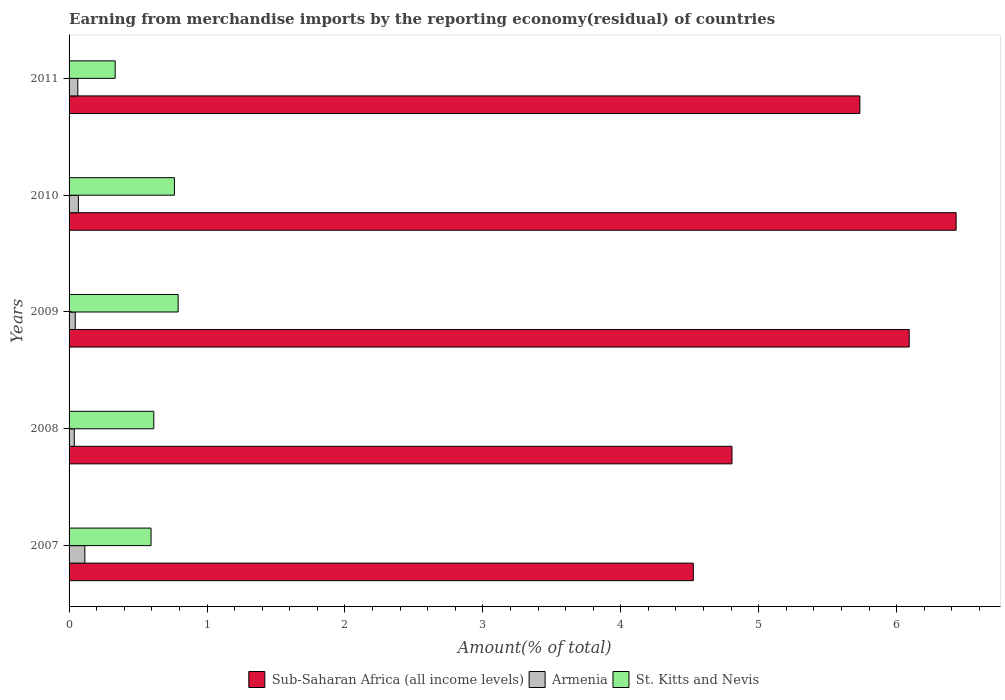How many groups of bars are there?
Your response must be concise. 5. How many bars are there on the 4th tick from the bottom?
Keep it short and to the point. 3. What is the label of the 5th group of bars from the top?
Offer a terse response. 2007. In how many cases, is the number of bars for a given year not equal to the number of legend labels?
Your answer should be compact. 0. What is the percentage of amount earned from merchandise imports in Armenia in 2011?
Provide a short and direct response. 0.06. Across all years, what is the maximum percentage of amount earned from merchandise imports in Armenia?
Ensure brevity in your answer.  0.11. Across all years, what is the minimum percentage of amount earned from merchandise imports in Sub-Saharan Africa (all income levels)?
Provide a short and direct response. 4.53. In which year was the percentage of amount earned from merchandise imports in Armenia maximum?
Your answer should be compact. 2007. What is the total percentage of amount earned from merchandise imports in Sub-Saharan Africa (all income levels) in the graph?
Your answer should be compact. 27.59. What is the difference between the percentage of amount earned from merchandise imports in Sub-Saharan Africa (all income levels) in 2008 and that in 2010?
Keep it short and to the point. -1.63. What is the difference between the percentage of amount earned from merchandise imports in Sub-Saharan Africa (all income levels) in 2011 and the percentage of amount earned from merchandise imports in Armenia in 2007?
Make the answer very short. 5.62. What is the average percentage of amount earned from merchandise imports in Armenia per year?
Offer a terse response. 0.07. In the year 2011, what is the difference between the percentage of amount earned from merchandise imports in Armenia and percentage of amount earned from merchandise imports in Sub-Saharan Africa (all income levels)?
Ensure brevity in your answer.  -5.67. What is the ratio of the percentage of amount earned from merchandise imports in Armenia in 2008 to that in 2009?
Offer a very short reply. 0.84. Is the percentage of amount earned from merchandise imports in Armenia in 2008 less than that in 2011?
Provide a short and direct response. Yes. Is the difference between the percentage of amount earned from merchandise imports in Armenia in 2008 and 2011 greater than the difference between the percentage of amount earned from merchandise imports in Sub-Saharan Africa (all income levels) in 2008 and 2011?
Ensure brevity in your answer.  Yes. What is the difference between the highest and the second highest percentage of amount earned from merchandise imports in Armenia?
Offer a terse response. 0.05. What is the difference between the highest and the lowest percentage of amount earned from merchandise imports in Sub-Saharan Africa (all income levels)?
Your answer should be very brief. 1.91. Is the sum of the percentage of amount earned from merchandise imports in Sub-Saharan Africa (all income levels) in 2007 and 2009 greater than the maximum percentage of amount earned from merchandise imports in St. Kitts and Nevis across all years?
Your response must be concise. Yes. What does the 2nd bar from the top in 2007 represents?
Make the answer very short. Armenia. What does the 1st bar from the bottom in 2011 represents?
Make the answer very short. Sub-Saharan Africa (all income levels). Is it the case that in every year, the sum of the percentage of amount earned from merchandise imports in St. Kitts and Nevis and percentage of amount earned from merchandise imports in Armenia is greater than the percentage of amount earned from merchandise imports in Sub-Saharan Africa (all income levels)?
Ensure brevity in your answer.  No. Does the graph contain grids?
Your answer should be compact. No. Where does the legend appear in the graph?
Provide a short and direct response. Bottom center. How many legend labels are there?
Offer a very short reply. 3. How are the legend labels stacked?
Your answer should be very brief. Horizontal. What is the title of the graph?
Your answer should be compact. Earning from merchandise imports by the reporting economy(residual) of countries. Does "Somalia" appear as one of the legend labels in the graph?
Provide a short and direct response. No. What is the label or title of the X-axis?
Give a very brief answer. Amount(% of total). What is the Amount(% of total) in Sub-Saharan Africa (all income levels) in 2007?
Offer a terse response. 4.53. What is the Amount(% of total) in Armenia in 2007?
Provide a succinct answer. 0.11. What is the Amount(% of total) of St. Kitts and Nevis in 2007?
Provide a succinct answer. 0.59. What is the Amount(% of total) in Sub-Saharan Africa (all income levels) in 2008?
Offer a very short reply. 4.81. What is the Amount(% of total) of Armenia in 2008?
Provide a short and direct response. 0.04. What is the Amount(% of total) of St. Kitts and Nevis in 2008?
Offer a terse response. 0.61. What is the Amount(% of total) of Sub-Saharan Africa (all income levels) in 2009?
Provide a succinct answer. 6.09. What is the Amount(% of total) in Armenia in 2009?
Provide a succinct answer. 0.04. What is the Amount(% of total) of St. Kitts and Nevis in 2009?
Ensure brevity in your answer.  0.79. What is the Amount(% of total) of Sub-Saharan Africa (all income levels) in 2010?
Provide a short and direct response. 6.43. What is the Amount(% of total) of Armenia in 2010?
Your response must be concise. 0.07. What is the Amount(% of total) in St. Kitts and Nevis in 2010?
Provide a succinct answer. 0.76. What is the Amount(% of total) of Sub-Saharan Africa (all income levels) in 2011?
Your response must be concise. 5.73. What is the Amount(% of total) of Armenia in 2011?
Your response must be concise. 0.06. What is the Amount(% of total) of St. Kitts and Nevis in 2011?
Provide a short and direct response. 0.33. Across all years, what is the maximum Amount(% of total) of Sub-Saharan Africa (all income levels)?
Ensure brevity in your answer.  6.43. Across all years, what is the maximum Amount(% of total) in Armenia?
Your answer should be very brief. 0.11. Across all years, what is the maximum Amount(% of total) in St. Kitts and Nevis?
Offer a very short reply. 0.79. Across all years, what is the minimum Amount(% of total) of Sub-Saharan Africa (all income levels)?
Give a very brief answer. 4.53. Across all years, what is the minimum Amount(% of total) of Armenia?
Keep it short and to the point. 0.04. Across all years, what is the minimum Amount(% of total) in St. Kitts and Nevis?
Offer a very short reply. 0.33. What is the total Amount(% of total) in Sub-Saharan Africa (all income levels) in the graph?
Provide a succinct answer. 27.59. What is the total Amount(% of total) in Armenia in the graph?
Your answer should be compact. 0.33. What is the total Amount(% of total) in St. Kitts and Nevis in the graph?
Make the answer very short. 3.1. What is the difference between the Amount(% of total) of Sub-Saharan Africa (all income levels) in 2007 and that in 2008?
Your answer should be compact. -0.28. What is the difference between the Amount(% of total) in Armenia in 2007 and that in 2008?
Make the answer very short. 0.08. What is the difference between the Amount(% of total) of St. Kitts and Nevis in 2007 and that in 2008?
Ensure brevity in your answer.  -0.02. What is the difference between the Amount(% of total) in Sub-Saharan Africa (all income levels) in 2007 and that in 2009?
Offer a very short reply. -1.57. What is the difference between the Amount(% of total) of Armenia in 2007 and that in 2009?
Your answer should be very brief. 0.07. What is the difference between the Amount(% of total) in St. Kitts and Nevis in 2007 and that in 2009?
Offer a very short reply. -0.2. What is the difference between the Amount(% of total) of Sub-Saharan Africa (all income levels) in 2007 and that in 2010?
Your answer should be compact. -1.91. What is the difference between the Amount(% of total) of Armenia in 2007 and that in 2010?
Keep it short and to the point. 0.05. What is the difference between the Amount(% of total) in St. Kitts and Nevis in 2007 and that in 2010?
Keep it short and to the point. -0.17. What is the difference between the Amount(% of total) in Sub-Saharan Africa (all income levels) in 2007 and that in 2011?
Offer a very short reply. -1.21. What is the difference between the Amount(% of total) of Armenia in 2007 and that in 2011?
Give a very brief answer. 0.05. What is the difference between the Amount(% of total) in St. Kitts and Nevis in 2007 and that in 2011?
Make the answer very short. 0.26. What is the difference between the Amount(% of total) in Sub-Saharan Africa (all income levels) in 2008 and that in 2009?
Ensure brevity in your answer.  -1.28. What is the difference between the Amount(% of total) in Armenia in 2008 and that in 2009?
Make the answer very short. -0.01. What is the difference between the Amount(% of total) of St. Kitts and Nevis in 2008 and that in 2009?
Offer a very short reply. -0.18. What is the difference between the Amount(% of total) of Sub-Saharan Africa (all income levels) in 2008 and that in 2010?
Offer a very short reply. -1.63. What is the difference between the Amount(% of total) of Armenia in 2008 and that in 2010?
Offer a terse response. -0.03. What is the difference between the Amount(% of total) of St. Kitts and Nevis in 2008 and that in 2010?
Your answer should be compact. -0.15. What is the difference between the Amount(% of total) of Sub-Saharan Africa (all income levels) in 2008 and that in 2011?
Your response must be concise. -0.93. What is the difference between the Amount(% of total) of Armenia in 2008 and that in 2011?
Keep it short and to the point. -0.03. What is the difference between the Amount(% of total) in St. Kitts and Nevis in 2008 and that in 2011?
Provide a short and direct response. 0.28. What is the difference between the Amount(% of total) in Sub-Saharan Africa (all income levels) in 2009 and that in 2010?
Make the answer very short. -0.34. What is the difference between the Amount(% of total) in Armenia in 2009 and that in 2010?
Your answer should be compact. -0.02. What is the difference between the Amount(% of total) in St. Kitts and Nevis in 2009 and that in 2010?
Keep it short and to the point. 0.03. What is the difference between the Amount(% of total) of Sub-Saharan Africa (all income levels) in 2009 and that in 2011?
Offer a very short reply. 0.36. What is the difference between the Amount(% of total) of Armenia in 2009 and that in 2011?
Your response must be concise. -0.02. What is the difference between the Amount(% of total) in St. Kitts and Nevis in 2009 and that in 2011?
Give a very brief answer. 0.46. What is the difference between the Amount(% of total) in Sub-Saharan Africa (all income levels) in 2010 and that in 2011?
Ensure brevity in your answer.  0.7. What is the difference between the Amount(% of total) of Armenia in 2010 and that in 2011?
Keep it short and to the point. 0. What is the difference between the Amount(% of total) of St. Kitts and Nevis in 2010 and that in 2011?
Provide a succinct answer. 0.43. What is the difference between the Amount(% of total) in Sub-Saharan Africa (all income levels) in 2007 and the Amount(% of total) in Armenia in 2008?
Provide a succinct answer. 4.49. What is the difference between the Amount(% of total) in Sub-Saharan Africa (all income levels) in 2007 and the Amount(% of total) in St. Kitts and Nevis in 2008?
Your answer should be very brief. 3.91. What is the difference between the Amount(% of total) of Sub-Saharan Africa (all income levels) in 2007 and the Amount(% of total) of Armenia in 2009?
Provide a short and direct response. 4.48. What is the difference between the Amount(% of total) in Sub-Saharan Africa (all income levels) in 2007 and the Amount(% of total) in St. Kitts and Nevis in 2009?
Provide a succinct answer. 3.73. What is the difference between the Amount(% of total) of Armenia in 2007 and the Amount(% of total) of St. Kitts and Nevis in 2009?
Provide a short and direct response. -0.68. What is the difference between the Amount(% of total) in Sub-Saharan Africa (all income levels) in 2007 and the Amount(% of total) in Armenia in 2010?
Provide a short and direct response. 4.46. What is the difference between the Amount(% of total) in Sub-Saharan Africa (all income levels) in 2007 and the Amount(% of total) in St. Kitts and Nevis in 2010?
Offer a terse response. 3.76. What is the difference between the Amount(% of total) of Armenia in 2007 and the Amount(% of total) of St. Kitts and Nevis in 2010?
Provide a succinct answer. -0.65. What is the difference between the Amount(% of total) of Sub-Saharan Africa (all income levels) in 2007 and the Amount(% of total) of Armenia in 2011?
Offer a terse response. 4.46. What is the difference between the Amount(% of total) in Sub-Saharan Africa (all income levels) in 2007 and the Amount(% of total) in St. Kitts and Nevis in 2011?
Offer a terse response. 4.19. What is the difference between the Amount(% of total) in Armenia in 2007 and the Amount(% of total) in St. Kitts and Nevis in 2011?
Keep it short and to the point. -0.22. What is the difference between the Amount(% of total) in Sub-Saharan Africa (all income levels) in 2008 and the Amount(% of total) in Armenia in 2009?
Your answer should be compact. 4.76. What is the difference between the Amount(% of total) in Sub-Saharan Africa (all income levels) in 2008 and the Amount(% of total) in St. Kitts and Nevis in 2009?
Your response must be concise. 4.02. What is the difference between the Amount(% of total) of Armenia in 2008 and the Amount(% of total) of St. Kitts and Nevis in 2009?
Keep it short and to the point. -0.75. What is the difference between the Amount(% of total) of Sub-Saharan Africa (all income levels) in 2008 and the Amount(% of total) of Armenia in 2010?
Offer a very short reply. 4.74. What is the difference between the Amount(% of total) of Sub-Saharan Africa (all income levels) in 2008 and the Amount(% of total) of St. Kitts and Nevis in 2010?
Offer a terse response. 4.04. What is the difference between the Amount(% of total) in Armenia in 2008 and the Amount(% of total) in St. Kitts and Nevis in 2010?
Make the answer very short. -0.73. What is the difference between the Amount(% of total) of Sub-Saharan Africa (all income levels) in 2008 and the Amount(% of total) of Armenia in 2011?
Provide a short and direct response. 4.74. What is the difference between the Amount(% of total) in Sub-Saharan Africa (all income levels) in 2008 and the Amount(% of total) in St. Kitts and Nevis in 2011?
Your answer should be very brief. 4.47. What is the difference between the Amount(% of total) in Armenia in 2008 and the Amount(% of total) in St. Kitts and Nevis in 2011?
Offer a terse response. -0.3. What is the difference between the Amount(% of total) in Sub-Saharan Africa (all income levels) in 2009 and the Amount(% of total) in Armenia in 2010?
Provide a succinct answer. 6.02. What is the difference between the Amount(% of total) of Sub-Saharan Africa (all income levels) in 2009 and the Amount(% of total) of St. Kitts and Nevis in 2010?
Ensure brevity in your answer.  5.33. What is the difference between the Amount(% of total) in Armenia in 2009 and the Amount(% of total) in St. Kitts and Nevis in 2010?
Keep it short and to the point. -0.72. What is the difference between the Amount(% of total) of Sub-Saharan Africa (all income levels) in 2009 and the Amount(% of total) of Armenia in 2011?
Provide a short and direct response. 6.03. What is the difference between the Amount(% of total) in Sub-Saharan Africa (all income levels) in 2009 and the Amount(% of total) in St. Kitts and Nevis in 2011?
Give a very brief answer. 5.76. What is the difference between the Amount(% of total) of Armenia in 2009 and the Amount(% of total) of St. Kitts and Nevis in 2011?
Ensure brevity in your answer.  -0.29. What is the difference between the Amount(% of total) of Sub-Saharan Africa (all income levels) in 2010 and the Amount(% of total) of Armenia in 2011?
Provide a succinct answer. 6.37. What is the difference between the Amount(% of total) of Sub-Saharan Africa (all income levels) in 2010 and the Amount(% of total) of St. Kitts and Nevis in 2011?
Your answer should be very brief. 6.1. What is the difference between the Amount(% of total) in Armenia in 2010 and the Amount(% of total) in St. Kitts and Nevis in 2011?
Your response must be concise. -0.27. What is the average Amount(% of total) of Sub-Saharan Africa (all income levels) per year?
Provide a short and direct response. 5.52. What is the average Amount(% of total) in Armenia per year?
Your response must be concise. 0.07. What is the average Amount(% of total) in St. Kitts and Nevis per year?
Provide a succinct answer. 0.62. In the year 2007, what is the difference between the Amount(% of total) of Sub-Saharan Africa (all income levels) and Amount(% of total) of Armenia?
Keep it short and to the point. 4.41. In the year 2007, what is the difference between the Amount(% of total) of Sub-Saharan Africa (all income levels) and Amount(% of total) of St. Kitts and Nevis?
Your response must be concise. 3.93. In the year 2007, what is the difference between the Amount(% of total) in Armenia and Amount(% of total) in St. Kitts and Nevis?
Provide a succinct answer. -0.48. In the year 2008, what is the difference between the Amount(% of total) of Sub-Saharan Africa (all income levels) and Amount(% of total) of Armenia?
Provide a short and direct response. 4.77. In the year 2008, what is the difference between the Amount(% of total) of Sub-Saharan Africa (all income levels) and Amount(% of total) of St. Kitts and Nevis?
Your response must be concise. 4.19. In the year 2008, what is the difference between the Amount(% of total) of Armenia and Amount(% of total) of St. Kitts and Nevis?
Make the answer very short. -0.58. In the year 2009, what is the difference between the Amount(% of total) in Sub-Saharan Africa (all income levels) and Amount(% of total) in Armenia?
Provide a succinct answer. 6.05. In the year 2009, what is the difference between the Amount(% of total) in Armenia and Amount(% of total) in St. Kitts and Nevis?
Your answer should be very brief. -0.75. In the year 2010, what is the difference between the Amount(% of total) of Sub-Saharan Africa (all income levels) and Amount(% of total) of Armenia?
Give a very brief answer. 6.36. In the year 2010, what is the difference between the Amount(% of total) in Sub-Saharan Africa (all income levels) and Amount(% of total) in St. Kitts and Nevis?
Give a very brief answer. 5.67. In the year 2010, what is the difference between the Amount(% of total) of Armenia and Amount(% of total) of St. Kitts and Nevis?
Offer a very short reply. -0.7. In the year 2011, what is the difference between the Amount(% of total) in Sub-Saharan Africa (all income levels) and Amount(% of total) in Armenia?
Your answer should be very brief. 5.67. In the year 2011, what is the difference between the Amount(% of total) of Sub-Saharan Africa (all income levels) and Amount(% of total) of St. Kitts and Nevis?
Provide a succinct answer. 5.4. In the year 2011, what is the difference between the Amount(% of total) in Armenia and Amount(% of total) in St. Kitts and Nevis?
Your answer should be compact. -0.27. What is the ratio of the Amount(% of total) of Sub-Saharan Africa (all income levels) in 2007 to that in 2008?
Make the answer very short. 0.94. What is the ratio of the Amount(% of total) in Armenia in 2007 to that in 2008?
Make the answer very short. 3.03. What is the ratio of the Amount(% of total) in St. Kitts and Nevis in 2007 to that in 2008?
Keep it short and to the point. 0.97. What is the ratio of the Amount(% of total) in Sub-Saharan Africa (all income levels) in 2007 to that in 2009?
Keep it short and to the point. 0.74. What is the ratio of the Amount(% of total) of Armenia in 2007 to that in 2009?
Your answer should be compact. 2.54. What is the ratio of the Amount(% of total) of St. Kitts and Nevis in 2007 to that in 2009?
Ensure brevity in your answer.  0.75. What is the ratio of the Amount(% of total) in Sub-Saharan Africa (all income levels) in 2007 to that in 2010?
Give a very brief answer. 0.7. What is the ratio of the Amount(% of total) of Armenia in 2007 to that in 2010?
Ensure brevity in your answer.  1.69. What is the ratio of the Amount(% of total) in St. Kitts and Nevis in 2007 to that in 2010?
Offer a terse response. 0.78. What is the ratio of the Amount(% of total) in Sub-Saharan Africa (all income levels) in 2007 to that in 2011?
Make the answer very short. 0.79. What is the ratio of the Amount(% of total) of Armenia in 2007 to that in 2011?
Offer a very short reply. 1.8. What is the ratio of the Amount(% of total) in St. Kitts and Nevis in 2007 to that in 2011?
Provide a short and direct response. 1.78. What is the ratio of the Amount(% of total) of Sub-Saharan Africa (all income levels) in 2008 to that in 2009?
Offer a very short reply. 0.79. What is the ratio of the Amount(% of total) of Armenia in 2008 to that in 2009?
Provide a short and direct response. 0.84. What is the ratio of the Amount(% of total) in St. Kitts and Nevis in 2008 to that in 2009?
Your answer should be compact. 0.78. What is the ratio of the Amount(% of total) of Sub-Saharan Africa (all income levels) in 2008 to that in 2010?
Your answer should be very brief. 0.75. What is the ratio of the Amount(% of total) of Armenia in 2008 to that in 2010?
Give a very brief answer. 0.56. What is the ratio of the Amount(% of total) in St. Kitts and Nevis in 2008 to that in 2010?
Your answer should be very brief. 0.8. What is the ratio of the Amount(% of total) in Sub-Saharan Africa (all income levels) in 2008 to that in 2011?
Provide a short and direct response. 0.84. What is the ratio of the Amount(% of total) in Armenia in 2008 to that in 2011?
Offer a very short reply. 0.6. What is the ratio of the Amount(% of total) in St. Kitts and Nevis in 2008 to that in 2011?
Give a very brief answer. 1.84. What is the ratio of the Amount(% of total) in Sub-Saharan Africa (all income levels) in 2009 to that in 2010?
Your answer should be very brief. 0.95. What is the ratio of the Amount(% of total) in Armenia in 2009 to that in 2010?
Your response must be concise. 0.67. What is the ratio of the Amount(% of total) in St. Kitts and Nevis in 2009 to that in 2010?
Your answer should be compact. 1.04. What is the ratio of the Amount(% of total) in Sub-Saharan Africa (all income levels) in 2009 to that in 2011?
Provide a short and direct response. 1.06. What is the ratio of the Amount(% of total) in Armenia in 2009 to that in 2011?
Give a very brief answer. 0.71. What is the ratio of the Amount(% of total) of St. Kitts and Nevis in 2009 to that in 2011?
Give a very brief answer. 2.37. What is the ratio of the Amount(% of total) in Sub-Saharan Africa (all income levels) in 2010 to that in 2011?
Keep it short and to the point. 1.12. What is the ratio of the Amount(% of total) in Armenia in 2010 to that in 2011?
Give a very brief answer. 1.07. What is the ratio of the Amount(% of total) of St. Kitts and Nevis in 2010 to that in 2011?
Offer a very short reply. 2.28. What is the difference between the highest and the second highest Amount(% of total) in Sub-Saharan Africa (all income levels)?
Offer a very short reply. 0.34. What is the difference between the highest and the second highest Amount(% of total) of Armenia?
Give a very brief answer. 0.05. What is the difference between the highest and the second highest Amount(% of total) of St. Kitts and Nevis?
Ensure brevity in your answer.  0.03. What is the difference between the highest and the lowest Amount(% of total) of Sub-Saharan Africa (all income levels)?
Provide a succinct answer. 1.91. What is the difference between the highest and the lowest Amount(% of total) in Armenia?
Your answer should be very brief. 0.08. What is the difference between the highest and the lowest Amount(% of total) in St. Kitts and Nevis?
Keep it short and to the point. 0.46. 